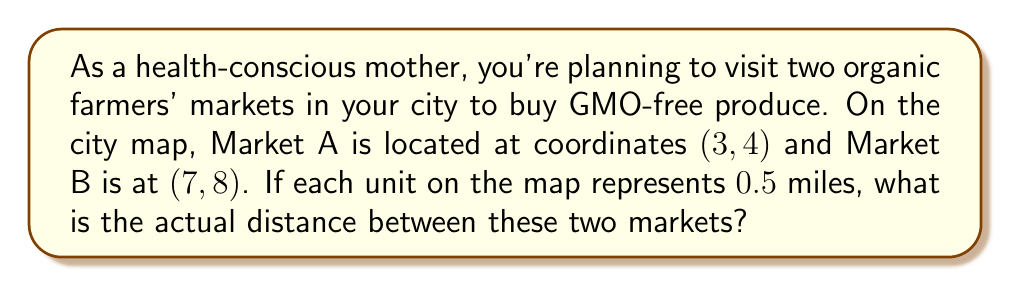Can you answer this question? Let's approach this step-by-step:

1) We can use the distance formula to find the distance between two points on a coordinate plane:
   
   $$d = \sqrt{(x_2 - x_1)^2 + (y_2 - y_1)^2}$$

   Where $(x_1, y_1)$ is the coordinate of the first point and $(x_2, y_2)$ is the coordinate of the second point.

2) In this case:
   Market A: $(x_1, y_1) = (3, 4)$
   Market B: $(x_2, y_2) = (7, 8)$

3) Let's plug these into the formula:

   $$d = \sqrt{(7 - 3)^2 + (8 - 4)^2}$$

4) Simplify inside the parentheses:

   $$d = \sqrt{4^2 + 4^2}$$

5) Calculate the squares:

   $$d = \sqrt{16 + 16}$$

6) Add inside the square root:

   $$d = \sqrt{32}$$

7) Simplify the square root:

   $$d = 4\sqrt{2}$$

8) This gives us the distance in map units. To convert to miles, we multiply by 0.5:

   $$\text{Actual distance} = 4\sqrt{2} \times 0.5 = 2\sqrt{2} \text{ miles}$$

Therefore, the actual distance between the two markets is $2\sqrt{2}$ miles.
Answer: $2\sqrt{2}$ miles 